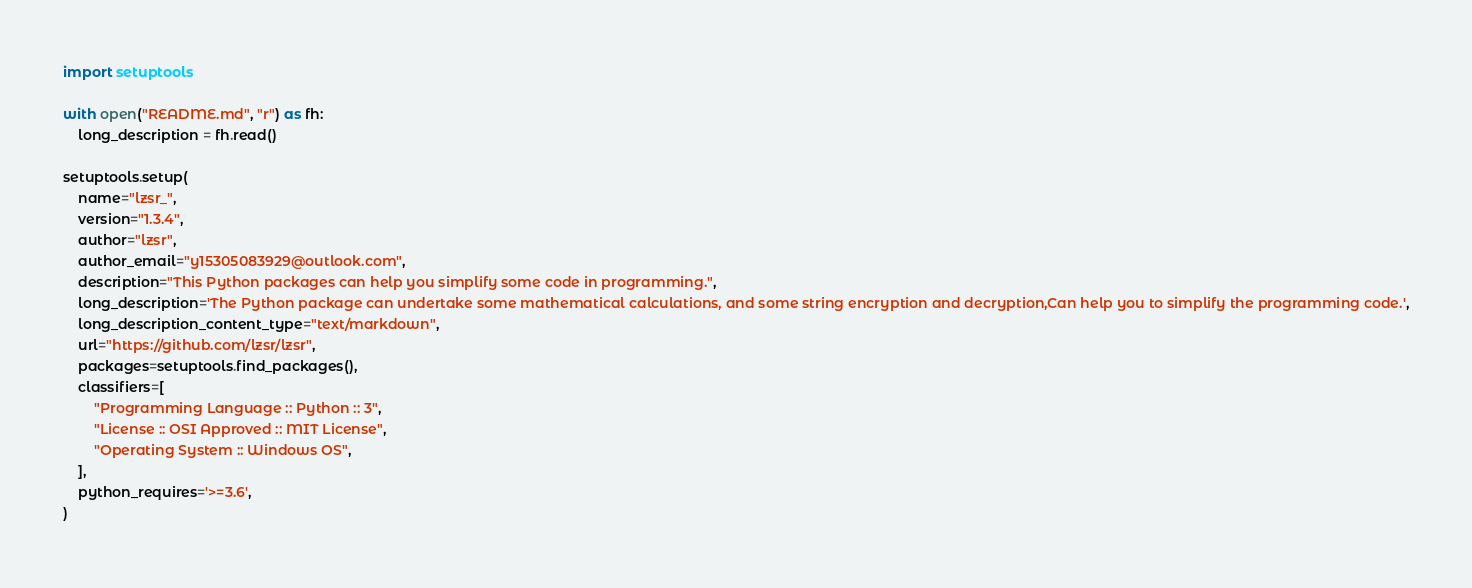<code> <loc_0><loc_0><loc_500><loc_500><_Python_>import setuptools

with open("README.md", "r") as fh:
    long_description = fh.read()

setuptools.setup(
    name="lzsr_",
    version="1.3.4",
    author="lzsr",
    author_email="y15305083929@outlook.com",
    description="This Python packages can help you simplify some code in programming.",
    long_description='The Python package can undertake some mathematical calculations, and some string encryption and decryption,Can help you to simplify the programming code.',
    long_description_content_type="text/markdown",
    url="https://github.com/lzsr/lzsr",
    packages=setuptools.find_packages(),
    classifiers=[
        "Programming Language :: Python :: 3",
        "License :: OSI Approved :: MIT License",
        "Operating System :: Windows OS",
    ],
    python_requires='>=3.6',
)</code> 